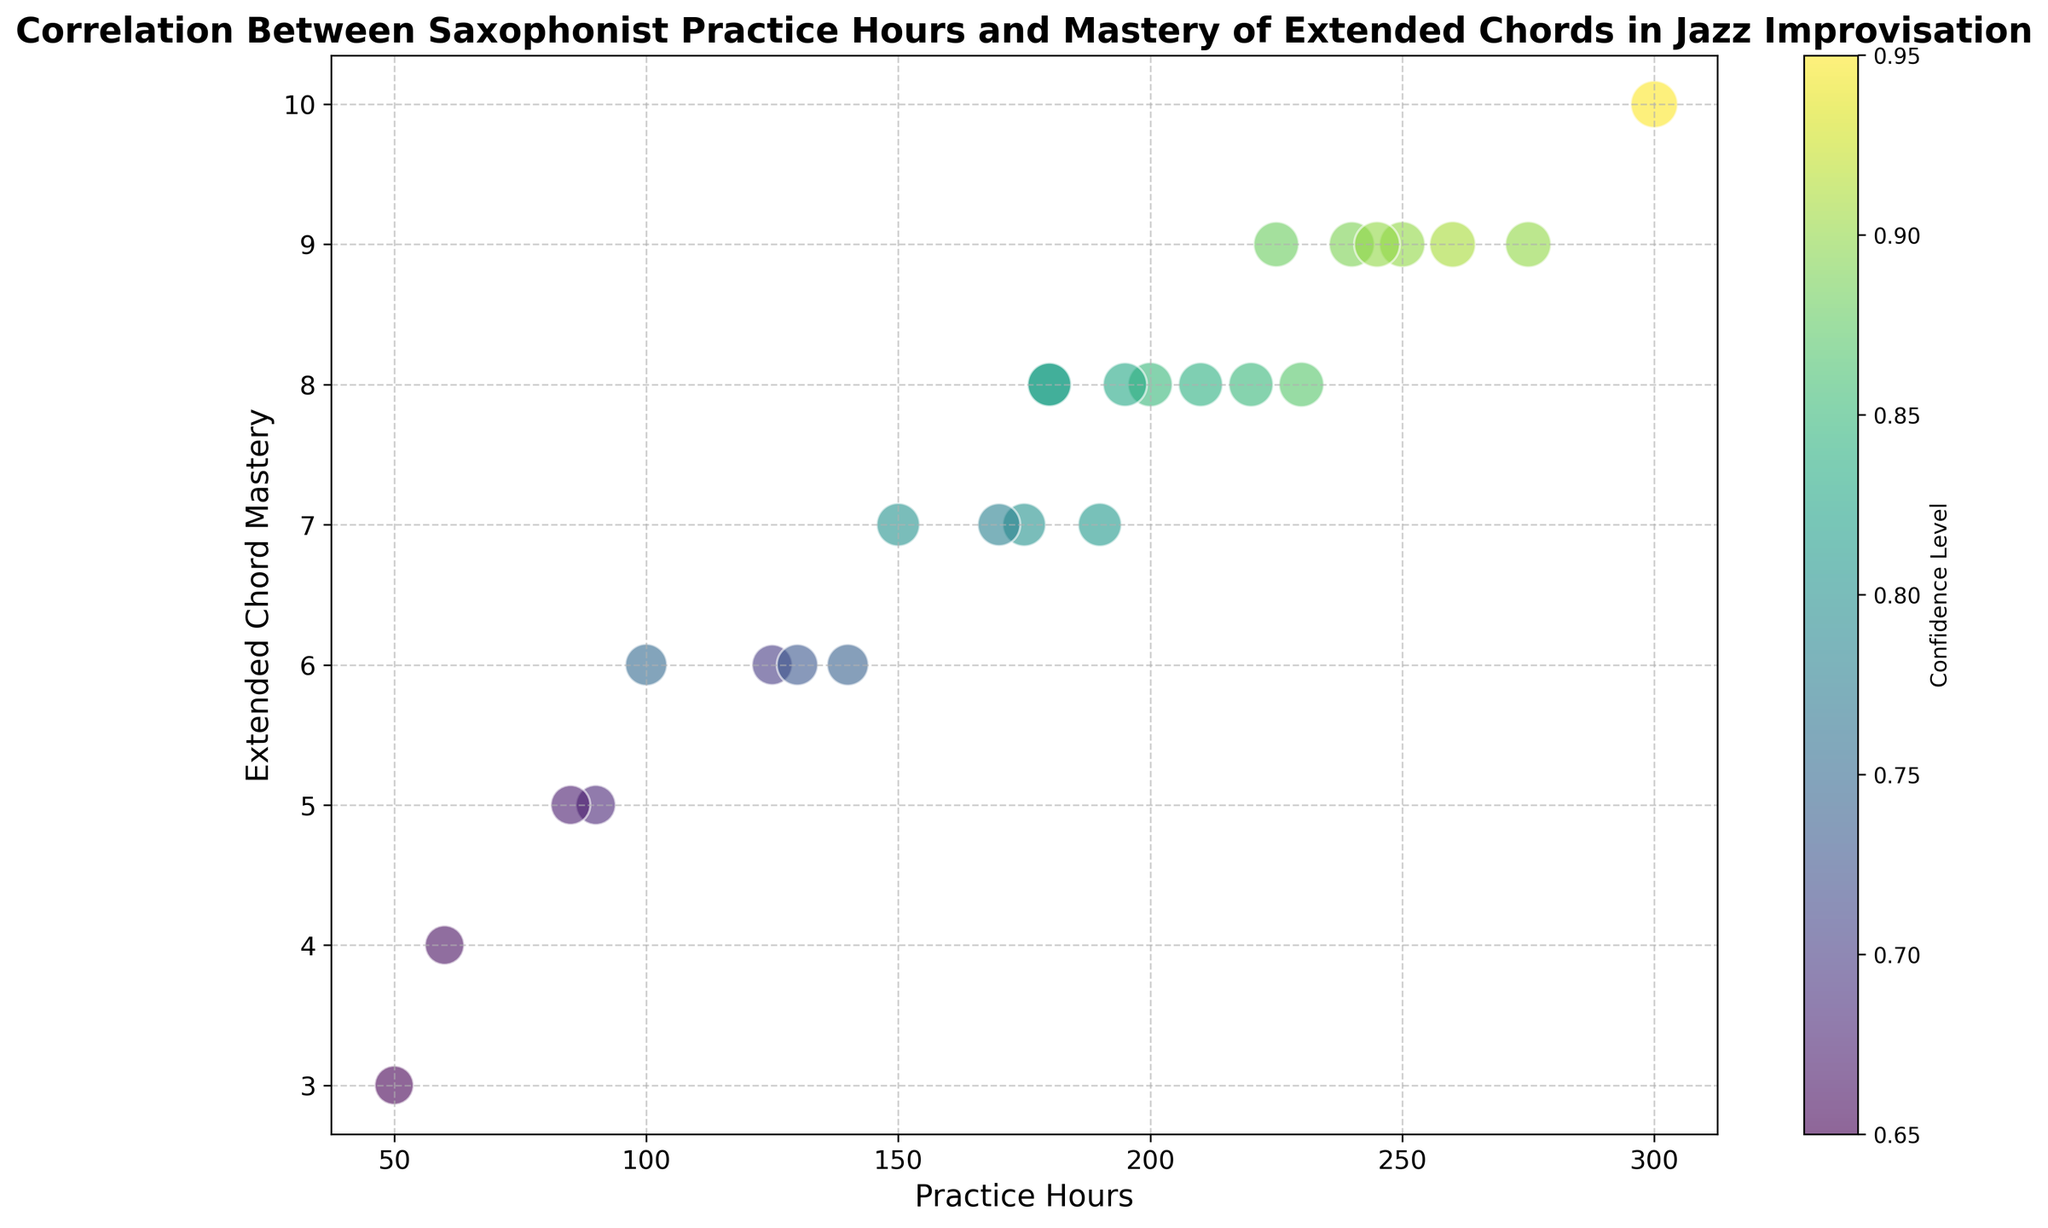What is the relationship between practice hours and extended chord mastery? By observing the trend in the scatter plot, we can see that as the number of practice hours increases, the mastery of extended chords also increases consistently. This indicates a positive correlation between practice hours and mastery of extended chords
Answer: Positive correlation Which saxophonist has the highest extended chord mastery and how many practice hours did they log? Ethan has the highest extended chord mastery of 10. The bubble corresponding to Ethan is at the highest point on the y-axis at 10, and the corresponding x-axis value is 300 practice hours
Answer: Ethan, 300 hours Which saxophonist has the lowest confidence level, and what is their extended chord mastery? Fiona has the lowest confidence level at 0.65. In the plot, Fiona's bubble is the smallest and is at the coordinate (50, 3) which corresponds to 3 in extended chord mastery
Answer: Fiona, 3 What is the median practice hours for the saxophonists showing mastery of 8 in extended chords? The saxophonists with mastery level 8 are Bob, Kevin, Natalie, Rita, Sam, and Xander with practice hours of 200, 220, 180, 195, 210, and 230 respectively. The median is calculated by ordering the numbers (180, 195, 200, 210, 220, 230) and finding the middle value, which is the average of 200 and 210
Answer: 205 hours Compare the confidence levels of saxophonists with 9 in extended chord mastery. Who has the highest confidence level and what is it? The saxophonists with 9 in extended chord mastery are Denise, Hannah, Ian, Oliver, Victor, and Zach with confidence levels of 0.9, 0.88, 0.9, 0.89, 0.91, and 0.9 respectively. The highest confidence level among them is 0.91 which belongs to Victor
Answer: Victor, 0.91 Which saxophonist has the same practice hours as Bob but a different extended chord mastery level? What is their mastery level? Uma has the same practice hours as Bob at 200 hours but a different extended chord mastery level of 7. Bob's bubble is at (200, 8) while Uma's bubble is at (200, 7)
Answer: Uma, 7 Identify the saxophonist who practices the least and describe their confidence level and extended chord mastery. Fiona practices the least with only 50 hours. Her confidence level is 0.65 and her extended chord mastery is 3. This is seen in the smallest bubble at the lowest x-axis value of 50
Answer: Fiona, 0.65, 3 What is the average extended chord mastery for saxophonists with over 200 practice hours? The saxophonists with over 200 practice hours are Denise (250, 9), Ethan (300, 10), Hannah (225, 9), Ian (275, 9), Kevin (220, 8), Oliver (240, 9), Victor (260, 9), and Zach (245, 9). The extended chord mastery values are 9, 10, 9, 9, 8, 9, 9, 9 respectively. The average is calculated as (9 + 10 + 9 + 9 + 8 + 9 + 9 + 9) / 8 = 9
Answer: 9 What does the color intensity of the bubbles signify in the plot? The color intensity of the bubbles represents the confidence level, where a deeper color corresponds to a higher confidence level. This is indicated by the color bar on the right side of the plot
Answer: Confidence level Compare the practice hours and extended chord mastery between Alice and George. Who has practiced more and who has a higher extended chord mastery? Alice has 150 practice hours and an extended chord mastery of 7. George has 175 practice hours and the same extended chord mastery of 7. Therefore, George has practiced more hours but they have the same level of extended chord mastery
Answer: George, Same mastery level 